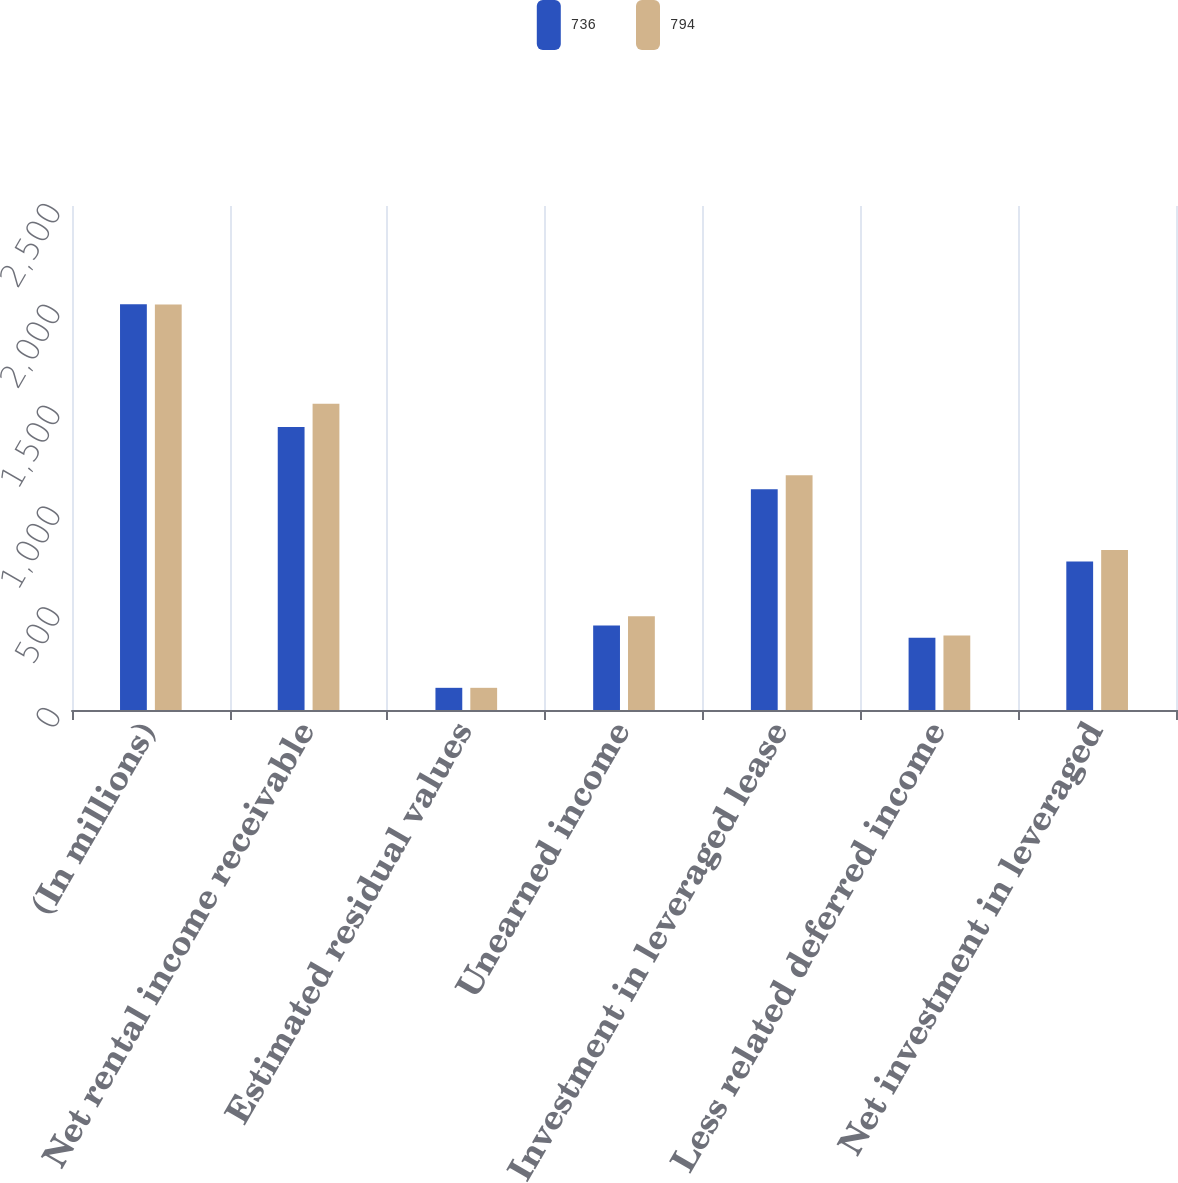Convert chart to OTSL. <chart><loc_0><loc_0><loc_500><loc_500><stacked_bar_chart><ecel><fcel>(In millions)<fcel>Net rental income receivable<fcel>Estimated residual values<fcel>Unearned income<fcel>Investment in leveraged lease<fcel>Less related deferred income<fcel>Net investment in leveraged<nl><fcel>736<fcel>2013<fcel>1404<fcel>110<fcel>419<fcel>1095<fcel>359<fcel>736<nl><fcel>794<fcel>2012<fcel>1519<fcel>110<fcel>465<fcel>1164<fcel>370<fcel>794<nl></chart> 